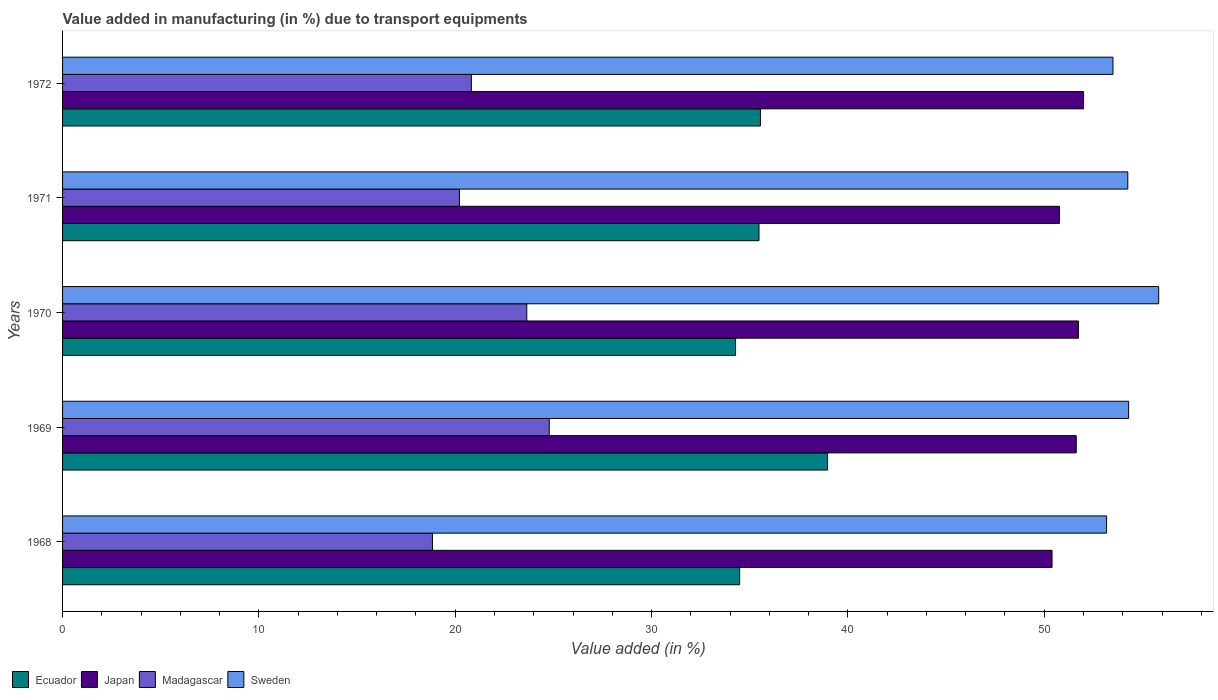Are the number of bars per tick equal to the number of legend labels?
Your response must be concise. Yes. Are the number of bars on each tick of the Y-axis equal?
Provide a short and direct response. Yes. What is the label of the 3rd group of bars from the top?
Your response must be concise. 1970. What is the percentage of value added in manufacturing due to transport equipments in Sweden in 1970?
Offer a very short reply. 55.83. Across all years, what is the maximum percentage of value added in manufacturing due to transport equipments in Ecuador?
Offer a terse response. 38.97. Across all years, what is the minimum percentage of value added in manufacturing due to transport equipments in Madagascar?
Your response must be concise. 18.84. In which year was the percentage of value added in manufacturing due to transport equipments in Japan maximum?
Give a very brief answer. 1972. In which year was the percentage of value added in manufacturing due to transport equipments in Japan minimum?
Offer a terse response. 1968. What is the total percentage of value added in manufacturing due to transport equipments in Sweden in the graph?
Your answer should be very brief. 271.06. What is the difference between the percentage of value added in manufacturing due to transport equipments in Madagascar in 1968 and that in 1969?
Provide a short and direct response. -5.95. What is the difference between the percentage of value added in manufacturing due to transport equipments in Madagascar in 1970 and the percentage of value added in manufacturing due to transport equipments in Sweden in 1972?
Your answer should be very brief. -29.86. What is the average percentage of value added in manufacturing due to transport equipments in Ecuador per year?
Provide a short and direct response. 35.75. In the year 1969, what is the difference between the percentage of value added in manufacturing due to transport equipments in Ecuador and percentage of value added in manufacturing due to transport equipments in Japan?
Your answer should be very brief. -12.66. In how many years, is the percentage of value added in manufacturing due to transport equipments in Madagascar greater than 22 %?
Offer a very short reply. 2. What is the ratio of the percentage of value added in manufacturing due to transport equipments in Madagascar in 1969 to that in 1972?
Provide a short and direct response. 1.19. Is the percentage of value added in manufacturing due to transport equipments in Japan in 1970 less than that in 1971?
Provide a short and direct response. No. Is the difference between the percentage of value added in manufacturing due to transport equipments in Ecuador in 1968 and 1969 greater than the difference between the percentage of value added in manufacturing due to transport equipments in Japan in 1968 and 1969?
Give a very brief answer. No. What is the difference between the highest and the second highest percentage of value added in manufacturing due to transport equipments in Ecuador?
Give a very brief answer. 3.42. What is the difference between the highest and the lowest percentage of value added in manufacturing due to transport equipments in Madagascar?
Your response must be concise. 5.95. In how many years, is the percentage of value added in manufacturing due to transport equipments in Sweden greater than the average percentage of value added in manufacturing due to transport equipments in Sweden taken over all years?
Provide a succinct answer. 3. Is it the case that in every year, the sum of the percentage of value added in manufacturing due to transport equipments in Ecuador and percentage of value added in manufacturing due to transport equipments in Madagascar is greater than the sum of percentage of value added in manufacturing due to transport equipments in Japan and percentage of value added in manufacturing due to transport equipments in Sweden?
Your answer should be very brief. No. What does the 3rd bar from the bottom in 1969 represents?
Your answer should be compact. Madagascar. Is it the case that in every year, the sum of the percentage of value added in manufacturing due to transport equipments in Japan and percentage of value added in manufacturing due to transport equipments in Madagascar is greater than the percentage of value added in manufacturing due to transport equipments in Sweden?
Your answer should be compact. Yes. How many bars are there?
Offer a very short reply. 20. How many years are there in the graph?
Your answer should be very brief. 5. Are the values on the major ticks of X-axis written in scientific E-notation?
Keep it short and to the point. No. Does the graph contain any zero values?
Your answer should be very brief. No. Does the graph contain grids?
Provide a succinct answer. No. How many legend labels are there?
Provide a short and direct response. 4. How are the legend labels stacked?
Provide a succinct answer. Horizontal. What is the title of the graph?
Offer a very short reply. Value added in manufacturing (in %) due to transport equipments. What is the label or title of the X-axis?
Offer a very short reply. Value added (in %). What is the Value added (in %) of Ecuador in 1968?
Make the answer very short. 34.49. What is the Value added (in %) in Japan in 1968?
Offer a terse response. 50.4. What is the Value added (in %) in Madagascar in 1968?
Offer a terse response. 18.84. What is the Value added (in %) in Sweden in 1968?
Provide a short and direct response. 53.17. What is the Value added (in %) in Ecuador in 1969?
Your response must be concise. 38.97. What is the Value added (in %) of Japan in 1969?
Give a very brief answer. 51.63. What is the Value added (in %) in Madagascar in 1969?
Your answer should be very brief. 24.79. What is the Value added (in %) in Sweden in 1969?
Offer a very short reply. 54.3. What is the Value added (in %) in Ecuador in 1970?
Ensure brevity in your answer.  34.28. What is the Value added (in %) in Japan in 1970?
Provide a succinct answer. 51.74. What is the Value added (in %) in Madagascar in 1970?
Give a very brief answer. 23.64. What is the Value added (in %) of Sweden in 1970?
Offer a terse response. 55.83. What is the Value added (in %) of Ecuador in 1971?
Offer a terse response. 35.47. What is the Value added (in %) of Japan in 1971?
Provide a short and direct response. 50.77. What is the Value added (in %) in Madagascar in 1971?
Offer a very short reply. 20.22. What is the Value added (in %) in Sweden in 1971?
Provide a short and direct response. 54.26. What is the Value added (in %) of Ecuador in 1972?
Offer a very short reply. 35.54. What is the Value added (in %) of Japan in 1972?
Keep it short and to the point. 52. What is the Value added (in %) in Madagascar in 1972?
Keep it short and to the point. 20.82. What is the Value added (in %) of Sweden in 1972?
Your answer should be compact. 53.5. Across all years, what is the maximum Value added (in %) of Ecuador?
Your answer should be compact. 38.97. Across all years, what is the maximum Value added (in %) in Japan?
Your answer should be compact. 52. Across all years, what is the maximum Value added (in %) of Madagascar?
Keep it short and to the point. 24.79. Across all years, what is the maximum Value added (in %) in Sweden?
Offer a very short reply. 55.83. Across all years, what is the minimum Value added (in %) in Ecuador?
Make the answer very short. 34.28. Across all years, what is the minimum Value added (in %) of Japan?
Your response must be concise. 50.4. Across all years, what is the minimum Value added (in %) of Madagascar?
Offer a very short reply. 18.84. Across all years, what is the minimum Value added (in %) of Sweden?
Your answer should be very brief. 53.17. What is the total Value added (in %) of Ecuador in the graph?
Your answer should be compact. 178.74. What is the total Value added (in %) in Japan in the graph?
Offer a terse response. 256.54. What is the total Value added (in %) in Madagascar in the graph?
Provide a succinct answer. 108.31. What is the total Value added (in %) in Sweden in the graph?
Your response must be concise. 271.06. What is the difference between the Value added (in %) of Ecuador in 1968 and that in 1969?
Offer a very short reply. -4.48. What is the difference between the Value added (in %) in Japan in 1968 and that in 1969?
Give a very brief answer. -1.23. What is the difference between the Value added (in %) of Madagascar in 1968 and that in 1969?
Make the answer very short. -5.95. What is the difference between the Value added (in %) of Sweden in 1968 and that in 1969?
Provide a succinct answer. -1.12. What is the difference between the Value added (in %) of Ecuador in 1968 and that in 1970?
Ensure brevity in your answer.  0.21. What is the difference between the Value added (in %) in Japan in 1968 and that in 1970?
Your answer should be compact. -1.35. What is the difference between the Value added (in %) of Madagascar in 1968 and that in 1970?
Give a very brief answer. -4.8. What is the difference between the Value added (in %) in Sweden in 1968 and that in 1970?
Provide a succinct answer. -2.65. What is the difference between the Value added (in %) in Ecuador in 1968 and that in 1971?
Your answer should be very brief. -0.99. What is the difference between the Value added (in %) of Japan in 1968 and that in 1971?
Provide a succinct answer. -0.38. What is the difference between the Value added (in %) in Madagascar in 1968 and that in 1971?
Offer a terse response. -1.38. What is the difference between the Value added (in %) of Sweden in 1968 and that in 1971?
Provide a short and direct response. -1.08. What is the difference between the Value added (in %) of Ecuador in 1968 and that in 1972?
Offer a very short reply. -1.06. What is the difference between the Value added (in %) of Japan in 1968 and that in 1972?
Provide a succinct answer. -1.61. What is the difference between the Value added (in %) in Madagascar in 1968 and that in 1972?
Keep it short and to the point. -1.98. What is the difference between the Value added (in %) in Sweden in 1968 and that in 1972?
Offer a very short reply. -0.33. What is the difference between the Value added (in %) in Ecuador in 1969 and that in 1970?
Provide a short and direct response. 4.69. What is the difference between the Value added (in %) in Japan in 1969 and that in 1970?
Your response must be concise. -0.11. What is the difference between the Value added (in %) in Madagascar in 1969 and that in 1970?
Offer a terse response. 1.14. What is the difference between the Value added (in %) of Sweden in 1969 and that in 1970?
Keep it short and to the point. -1.53. What is the difference between the Value added (in %) of Ecuador in 1969 and that in 1971?
Ensure brevity in your answer.  3.49. What is the difference between the Value added (in %) in Japan in 1969 and that in 1971?
Give a very brief answer. 0.86. What is the difference between the Value added (in %) in Madagascar in 1969 and that in 1971?
Offer a very short reply. 4.57. What is the difference between the Value added (in %) of Sweden in 1969 and that in 1971?
Keep it short and to the point. 0.04. What is the difference between the Value added (in %) in Ecuador in 1969 and that in 1972?
Give a very brief answer. 3.42. What is the difference between the Value added (in %) of Japan in 1969 and that in 1972?
Your response must be concise. -0.37. What is the difference between the Value added (in %) in Madagascar in 1969 and that in 1972?
Provide a short and direct response. 3.97. What is the difference between the Value added (in %) in Sweden in 1969 and that in 1972?
Your answer should be compact. 0.8. What is the difference between the Value added (in %) of Ecuador in 1970 and that in 1971?
Make the answer very short. -1.19. What is the difference between the Value added (in %) of Japan in 1970 and that in 1971?
Ensure brevity in your answer.  0.97. What is the difference between the Value added (in %) of Madagascar in 1970 and that in 1971?
Your answer should be very brief. 3.43. What is the difference between the Value added (in %) in Sweden in 1970 and that in 1971?
Your answer should be compact. 1.57. What is the difference between the Value added (in %) of Ecuador in 1970 and that in 1972?
Provide a short and direct response. -1.27. What is the difference between the Value added (in %) of Japan in 1970 and that in 1972?
Your answer should be very brief. -0.26. What is the difference between the Value added (in %) in Madagascar in 1970 and that in 1972?
Your response must be concise. 2.82. What is the difference between the Value added (in %) of Sweden in 1970 and that in 1972?
Your answer should be very brief. 2.33. What is the difference between the Value added (in %) in Ecuador in 1971 and that in 1972?
Ensure brevity in your answer.  -0.07. What is the difference between the Value added (in %) of Japan in 1971 and that in 1972?
Your answer should be compact. -1.23. What is the difference between the Value added (in %) in Madagascar in 1971 and that in 1972?
Provide a succinct answer. -0.61. What is the difference between the Value added (in %) in Sweden in 1971 and that in 1972?
Make the answer very short. 0.76. What is the difference between the Value added (in %) in Ecuador in 1968 and the Value added (in %) in Japan in 1969?
Keep it short and to the point. -17.14. What is the difference between the Value added (in %) of Ecuador in 1968 and the Value added (in %) of Madagascar in 1969?
Provide a succinct answer. 9.7. What is the difference between the Value added (in %) of Ecuador in 1968 and the Value added (in %) of Sweden in 1969?
Provide a short and direct response. -19.81. What is the difference between the Value added (in %) of Japan in 1968 and the Value added (in %) of Madagascar in 1969?
Provide a short and direct response. 25.61. What is the difference between the Value added (in %) of Japan in 1968 and the Value added (in %) of Sweden in 1969?
Keep it short and to the point. -3.9. What is the difference between the Value added (in %) of Madagascar in 1968 and the Value added (in %) of Sweden in 1969?
Give a very brief answer. -35.46. What is the difference between the Value added (in %) of Ecuador in 1968 and the Value added (in %) of Japan in 1970?
Your answer should be compact. -17.26. What is the difference between the Value added (in %) in Ecuador in 1968 and the Value added (in %) in Madagascar in 1970?
Provide a succinct answer. 10.84. What is the difference between the Value added (in %) in Ecuador in 1968 and the Value added (in %) in Sweden in 1970?
Provide a succinct answer. -21.34. What is the difference between the Value added (in %) of Japan in 1968 and the Value added (in %) of Madagascar in 1970?
Keep it short and to the point. 26.75. What is the difference between the Value added (in %) of Japan in 1968 and the Value added (in %) of Sweden in 1970?
Offer a very short reply. -5.43. What is the difference between the Value added (in %) in Madagascar in 1968 and the Value added (in %) in Sweden in 1970?
Make the answer very short. -36.99. What is the difference between the Value added (in %) of Ecuador in 1968 and the Value added (in %) of Japan in 1971?
Make the answer very short. -16.29. What is the difference between the Value added (in %) of Ecuador in 1968 and the Value added (in %) of Madagascar in 1971?
Give a very brief answer. 14.27. What is the difference between the Value added (in %) of Ecuador in 1968 and the Value added (in %) of Sweden in 1971?
Make the answer very short. -19.77. What is the difference between the Value added (in %) in Japan in 1968 and the Value added (in %) in Madagascar in 1971?
Your answer should be compact. 30.18. What is the difference between the Value added (in %) in Japan in 1968 and the Value added (in %) in Sweden in 1971?
Your answer should be compact. -3.86. What is the difference between the Value added (in %) in Madagascar in 1968 and the Value added (in %) in Sweden in 1971?
Make the answer very short. -35.42. What is the difference between the Value added (in %) of Ecuador in 1968 and the Value added (in %) of Japan in 1972?
Offer a terse response. -17.52. What is the difference between the Value added (in %) in Ecuador in 1968 and the Value added (in %) in Madagascar in 1972?
Keep it short and to the point. 13.66. What is the difference between the Value added (in %) in Ecuador in 1968 and the Value added (in %) in Sweden in 1972?
Your answer should be very brief. -19.02. What is the difference between the Value added (in %) in Japan in 1968 and the Value added (in %) in Madagascar in 1972?
Offer a terse response. 29.58. What is the difference between the Value added (in %) of Japan in 1968 and the Value added (in %) of Sweden in 1972?
Keep it short and to the point. -3.1. What is the difference between the Value added (in %) of Madagascar in 1968 and the Value added (in %) of Sweden in 1972?
Offer a terse response. -34.66. What is the difference between the Value added (in %) in Ecuador in 1969 and the Value added (in %) in Japan in 1970?
Your answer should be very brief. -12.78. What is the difference between the Value added (in %) of Ecuador in 1969 and the Value added (in %) of Madagascar in 1970?
Ensure brevity in your answer.  15.32. What is the difference between the Value added (in %) in Ecuador in 1969 and the Value added (in %) in Sweden in 1970?
Provide a short and direct response. -16.86. What is the difference between the Value added (in %) in Japan in 1969 and the Value added (in %) in Madagascar in 1970?
Your answer should be compact. 27.99. What is the difference between the Value added (in %) in Japan in 1969 and the Value added (in %) in Sweden in 1970?
Ensure brevity in your answer.  -4.2. What is the difference between the Value added (in %) of Madagascar in 1969 and the Value added (in %) of Sweden in 1970?
Give a very brief answer. -31.04. What is the difference between the Value added (in %) of Ecuador in 1969 and the Value added (in %) of Japan in 1971?
Your response must be concise. -11.81. What is the difference between the Value added (in %) in Ecuador in 1969 and the Value added (in %) in Madagascar in 1971?
Make the answer very short. 18.75. What is the difference between the Value added (in %) in Ecuador in 1969 and the Value added (in %) in Sweden in 1971?
Provide a succinct answer. -15.29. What is the difference between the Value added (in %) in Japan in 1969 and the Value added (in %) in Madagascar in 1971?
Make the answer very short. 31.41. What is the difference between the Value added (in %) of Japan in 1969 and the Value added (in %) of Sweden in 1971?
Make the answer very short. -2.63. What is the difference between the Value added (in %) in Madagascar in 1969 and the Value added (in %) in Sweden in 1971?
Your response must be concise. -29.47. What is the difference between the Value added (in %) in Ecuador in 1969 and the Value added (in %) in Japan in 1972?
Your answer should be compact. -13.04. What is the difference between the Value added (in %) of Ecuador in 1969 and the Value added (in %) of Madagascar in 1972?
Offer a terse response. 18.14. What is the difference between the Value added (in %) of Ecuador in 1969 and the Value added (in %) of Sweden in 1972?
Ensure brevity in your answer.  -14.54. What is the difference between the Value added (in %) of Japan in 1969 and the Value added (in %) of Madagascar in 1972?
Give a very brief answer. 30.81. What is the difference between the Value added (in %) of Japan in 1969 and the Value added (in %) of Sweden in 1972?
Offer a very short reply. -1.87. What is the difference between the Value added (in %) in Madagascar in 1969 and the Value added (in %) in Sweden in 1972?
Keep it short and to the point. -28.71. What is the difference between the Value added (in %) in Ecuador in 1970 and the Value added (in %) in Japan in 1971?
Offer a very short reply. -16.49. What is the difference between the Value added (in %) in Ecuador in 1970 and the Value added (in %) in Madagascar in 1971?
Provide a succinct answer. 14.06. What is the difference between the Value added (in %) of Ecuador in 1970 and the Value added (in %) of Sweden in 1971?
Provide a short and direct response. -19.98. What is the difference between the Value added (in %) of Japan in 1970 and the Value added (in %) of Madagascar in 1971?
Your answer should be very brief. 31.53. What is the difference between the Value added (in %) of Japan in 1970 and the Value added (in %) of Sweden in 1971?
Provide a short and direct response. -2.51. What is the difference between the Value added (in %) of Madagascar in 1970 and the Value added (in %) of Sweden in 1971?
Make the answer very short. -30.61. What is the difference between the Value added (in %) in Ecuador in 1970 and the Value added (in %) in Japan in 1972?
Your answer should be very brief. -17.73. What is the difference between the Value added (in %) in Ecuador in 1970 and the Value added (in %) in Madagascar in 1972?
Give a very brief answer. 13.46. What is the difference between the Value added (in %) in Ecuador in 1970 and the Value added (in %) in Sweden in 1972?
Give a very brief answer. -19.22. What is the difference between the Value added (in %) of Japan in 1970 and the Value added (in %) of Madagascar in 1972?
Provide a succinct answer. 30.92. What is the difference between the Value added (in %) of Japan in 1970 and the Value added (in %) of Sweden in 1972?
Your answer should be very brief. -1.76. What is the difference between the Value added (in %) in Madagascar in 1970 and the Value added (in %) in Sweden in 1972?
Keep it short and to the point. -29.86. What is the difference between the Value added (in %) in Ecuador in 1971 and the Value added (in %) in Japan in 1972?
Ensure brevity in your answer.  -16.53. What is the difference between the Value added (in %) of Ecuador in 1971 and the Value added (in %) of Madagascar in 1972?
Provide a succinct answer. 14.65. What is the difference between the Value added (in %) of Ecuador in 1971 and the Value added (in %) of Sweden in 1972?
Your response must be concise. -18.03. What is the difference between the Value added (in %) of Japan in 1971 and the Value added (in %) of Madagascar in 1972?
Keep it short and to the point. 29.95. What is the difference between the Value added (in %) in Japan in 1971 and the Value added (in %) in Sweden in 1972?
Offer a terse response. -2.73. What is the difference between the Value added (in %) in Madagascar in 1971 and the Value added (in %) in Sweden in 1972?
Offer a very short reply. -33.29. What is the average Value added (in %) in Ecuador per year?
Your response must be concise. 35.75. What is the average Value added (in %) in Japan per year?
Your response must be concise. 51.31. What is the average Value added (in %) of Madagascar per year?
Offer a very short reply. 21.66. What is the average Value added (in %) of Sweden per year?
Provide a short and direct response. 54.21. In the year 1968, what is the difference between the Value added (in %) in Ecuador and Value added (in %) in Japan?
Provide a short and direct response. -15.91. In the year 1968, what is the difference between the Value added (in %) in Ecuador and Value added (in %) in Madagascar?
Your answer should be compact. 15.65. In the year 1968, what is the difference between the Value added (in %) of Ecuador and Value added (in %) of Sweden?
Give a very brief answer. -18.69. In the year 1968, what is the difference between the Value added (in %) of Japan and Value added (in %) of Madagascar?
Your answer should be very brief. 31.56. In the year 1968, what is the difference between the Value added (in %) of Japan and Value added (in %) of Sweden?
Provide a succinct answer. -2.78. In the year 1968, what is the difference between the Value added (in %) of Madagascar and Value added (in %) of Sweden?
Offer a very short reply. -34.34. In the year 1969, what is the difference between the Value added (in %) in Ecuador and Value added (in %) in Japan?
Keep it short and to the point. -12.66. In the year 1969, what is the difference between the Value added (in %) in Ecuador and Value added (in %) in Madagascar?
Give a very brief answer. 14.18. In the year 1969, what is the difference between the Value added (in %) in Ecuador and Value added (in %) in Sweden?
Ensure brevity in your answer.  -15.33. In the year 1969, what is the difference between the Value added (in %) in Japan and Value added (in %) in Madagascar?
Your answer should be very brief. 26.84. In the year 1969, what is the difference between the Value added (in %) in Japan and Value added (in %) in Sweden?
Provide a succinct answer. -2.67. In the year 1969, what is the difference between the Value added (in %) in Madagascar and Value added (in %) in Sweden?
Provide a short and direct response. -29.51. In the year 1970, what is the difference between the Value added (in %) of Ecuador and Value added (in %) of Japan?
Offer a terse response. -17.47. In the year 1970, what is the difference between the Value added (in %) of Ecuador and Value added (in %) of Madagascar?
Provide a succinct answer. 10.63. In the year 1970, what is the difference between the Value added (in %) of Ecuador and Value added (in %) of Sweden?
Offer a very short reply. -21.55. In the year 1970, what is the difference between the Value added (in %) in Japan and Value added (in %) in Madagascar?
Your answer should be very brief. 28.1. In the year 1970, what is the difference between the Value added (in %) in Japan and Value added (in %) in Sweden?
Your response must be concise. -4.09. In the year 1970, what is the difference between the Value added (in %) of Madagascar and Value added (in %) of Sweden?
Keep it short and to the point. -32.18. In the year 1971, what is the difference between the Value added (in %) of Ecuador and Value added (in %) of Japan?
Your response must be concise. -15.3. In the year 1971, what is the difference between the Value added (in %) of Ecuador and Value added (in %) of Madagascar?
Give a very brief answer. 15.26. In the year 1971, what is the difference between the Value added (in %) in Ecuador and Value added (in %) in Sweden?
Offer a very short reply. -18.78. In the year 1971, what is the difference between the Value added (in %) of Japan and Value added (in %) of Madagascar?
Provide a short and direct response. 30.56. In the year 1971, what is the difference between the Value added (in %) in Japan and Value added (in %) in Sweden?
Offer a very short reply. -3.48. In the year 1971, what is the difference between the Value added (in %) of Madagascar and Value added (in %) of Sweden?
Your answer should be compact. -34.04. In the year 1972, what is the difference between the Value added (in %) in Ecuador and Value added (in %) in Japan?
Provide a succinct answer. -16.46. In the year 1972, what is the difference between the Value added (in %) in Ecuador and Value added (in %) in Madagascar?
Offer a terse response. 14.72. In the year 1972, what is the difference between the Value added (in %) of Ecuador and Value added (in %) of Sweden?
Keep it short and to the point. -17.96. In the year 1972, what is the difference between the Value added (in %) in Japan and Value added (in %) in Madagascar?
Your answer should be very brief. 31.18. In the year 1972, what is the difference between the Value added (in %) of Japan and Value added (in %) of Sweden?
Offer a terse response. -1.5. In the year 1972, what is the difference between the Value added (in %) of Madagascar and Value added (in %) of Sweden?
Provide a succinct answer. -32.68. What is the ratio of the Value added (in %) of Ecuador in 1968 to that in 1969?
Your response must be concise. 0.89. What is the ratio of the Value added (in %) in Japan in 1968 to that in 1969?
Offer a terse response. 0.98. What is the ratio of the Value added (in %) in Madagascar in 1968 to that in 1969?
Your answer should be compact. 0.76. What is the ratio of the Value added (in %) in Sweden in 1968 to that in 1969?
Provide a succinct answer. 0.98. What is the ratio of the Value added (in %) in Ecuador in 1968 to that in 1970?
Give a very brief answer. 1.01. What is the ratio of the Value added (in %) of Japan in 1968 to that in 1970?
Make the answer very short. 0.97. What is the ratio of the Value added (in %) in Madagascar in 1968 to that in 1970?
Ensure brevity in your answer.  0.8. What is the ratio of the Value added (in %) of Sweden in 1968 to that in 1970?
Ensure brevity in your answer.  0.95. What is the ratio of the Value added (in %) in Ecuador in 1968 to that in 1971?
Make the answer very short. 0.97. What is the ratio of the Value added (in %) in Madagascar in 1968 to that in 1971?
Offer a terse response. 0.93. What is the ratio of the Value added (in %) in Sweden in 1968 to that in 1971?
Keep it short and to the point. 0.98. What is the ratio of the Value added (in %) of Ecuador in 1968 to that in 1972?
Your answer should be very brief. 0.97. What is the ratio of the Value added (in %) in Japan in 1968 to that in 1972?
Your answer should be compact. 0.97. What is the ratio of the Value added (in %) of Madagascar in 1968 to that in 1972?
Provide a succinct answer. 0.9. What is the ratio of the Value added (in %) in Sweden in 1968 to that in 1972?
Your answer should be very brief. 0.99. What is the ratio of the Value added (in %) of Ecuador in 1969 to that in 1970?
Ensure brevity in your answer.  1.14. What is the ratio of the Value added (in %) of Madagascar in 1969 to that in 1970?
Provide a short and direct response. 1.05. What is the ratio of the Value added (in %) in Sweden in 1969 to that in 1970?
Give a very brief answer. 0.97. What is the ratio of the Value added (in %) of Ecuador in 1969 to that in 1971?
Provide a short and direct response. 1.1. What is the ratio of the Value added (in %) in Japan in 1969 to that in 1971?
Offer a very short reply. 1.02. What is the ratio of the Value added (in %) of Madagascar in 1969 to that in 1971?
Ensure brevity in your answer.  1.23. What is the ratio of the Value added (in %) of Ecuador in 1969 to that in 1972?
Offer a terse response. 1.1. What is the ratio of the Value added (in %) in Madagascar in 1969 to that in 1972?
Your response must be concise. 1.19. What is the ratio of the Value added (in %) of Sweden in 1969 to that in 1972?
Make the answer very short. 1.01. What is the ratio of the Value added (in %) in Ecuador in 1970 to that in 1971?
Offer a terse response. 0.97. What is the ratio of the Value added (in %) of Japan in 1970 to that in 1971?
Provide a short and direct response. 1.02. What is the ratio of the Value added (in %) in Madagascar in 1970 to that in 1971?
Ensure brevity in your answer.  1.17. What is the ratio of the Value added (in %) of Sweden in 1970 to that in 1971?
Give a very brief answer. 1.03. What is the ratio of the Value added (in %) of Ecuador in 1970 to that in 1972?
Ensure brevity in your answer.  0.96. What is the ratio of the Value added (in %) in Japan in 1970 to that in 1972?
Offer a very short reply. 0.99. What is the ratio of the Value added (in %) in Madagascar in 1970 to that in 1972?
Your answer should be very brief. 1.14. What is the ratio of the Value added (in %) in Sweden in 1970 to that in 1972?
Make the answer very short. 1.04. What is the ratio of the Value added (in %) in Japan in 1971 to that in 1972?
Make the answer very short. 0.98. What is the ratio of the Value added (in %) of Madagascar in 1971 to that in 1972?
Offer a very short reply. 0.97. What is the ratio of the Value added (in %) of Sweden in 1971 to that in 1972?
Your answer should be very brief. 1.01. What is the difference between the highest and the second highest Value added (in %) in Ecuador?
Provide a succinct answer. 3.42. What is the difference between the highest and the second highest Value added (in %) in Japan?
Make the answer very short. 0.26. What is the difference between the highest and the second highest Value added (in %) of Madagascar?
Keep it short and to the point. 1.14. What is the difference between the highest and the second highest Value added (in %) in Sweden?
Provide a succinct answer. 1.53. What is the difference between the highest and the lowest Value added (in %) in Ecuador?
Your answer should be compact. 4.69. What is the difference between the highest and the lowest Value added (in %) of Japan?
Provide a succinct answer. 1.61. What is the difference between the highest and the lowest Value added (in %) in Madagascar?
Make the answer very short. 5.95. What is the difference between the highest and the lowest Value added (in %) in Sweden?
Offer a very short reply. 2.65. 